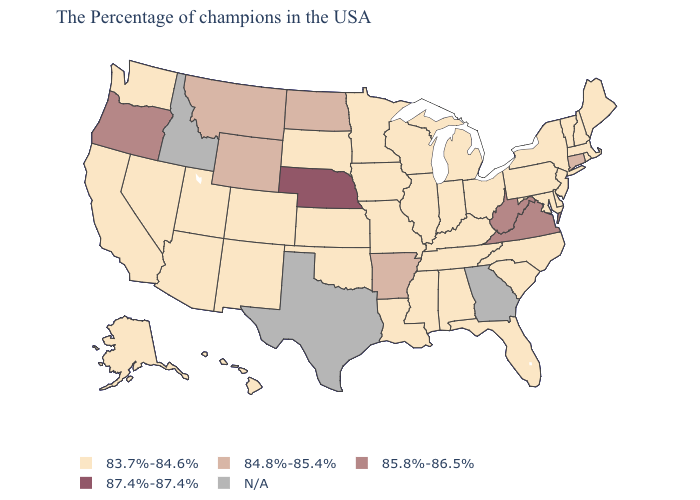Which states have the highest value in the USA?
Short answer required. Nebraska. Name the states that have a value in the range 83.7%-84.6%?
Keep it brief. Maine, Massachusetts, Rhode Island, New Hampshire, Vermont, New York, New Jersey, Delaware, Maryland, Pennsylvania, North Carolina, South Carolina, Ohio, Florida, Michigan, Kentucky, Indiana, Alabama, Tennessee, Wisconsin, Illinois, Mississippi, Louisiana, Missouri, Minnesota, Iowa, Kansas, Oklahoma, South Dakota, Colorado, New Mexico, Utah, Arizona, Nevada, California, Washington, Alaska, Hawaii. Name the states that have a value in the range 83.7%-84.6%?
Keep it brief. Maine, Massachusetts, Rhode Island, New Hampshire, Vermont, New York, New Jersey, Delaware, Maryland, Pennsylvania, North Carolina, South Carolina, Ohio, Florida, Michigan, Kentucky, Indiana, Alabama, Tennessee, Wisconsin, Illinois, Mississippi, Louisiana, Missouri, Minnesota, Iowa, Kansas, Oklahoma, South Dakota, Colorado, New Mexico, Utah, Arizona, Nevada, California, Washington, Alaska, Hawaii. Name the states that have a value in the range 84.8%-85.4%?
Write a very short answer. Connecticut, Arkansas, North Dakota, Wyoming, Montana. Which states have the lowest value in the Northeast?
Quick response, please. Maine, Massachusetts, Rhode Island, New Hampshire, Vermont, New York, New Jersey, Pennsylvania. Does the first symbol in the legend represent the smallest category?
Short answer required. Yes. Does the first symbol in the legend represent the smallest category?
Write a very short answer. Yes. Does the first symbol in the legend represent the smallest category?
Give a very brief answer. Yes. Is the legend a continuous bar?
Give a very brief answer. No. Name the states that have a value in the range 83.7%-84.6%?
Keep it brief. Maine, Massachusetts, Rhode Island, New Hampshire, Vermont, New York, New Jersey, Delaware, Maryland, Pennsylvania, North Carolina, South Carolina, Ohio, Florida, Michigan, Kentucky, Indiana, Alabama, Tennessee, Wisconsin, Illinois, Mississippi, Louisiana, Missouri, Minnesota, Iowa, Kansas, Oklahoma, South Dakota, Colorado, New Mexico, Utah, Arizona, Nevada, California, Washington, Alaska, Hawaii. Name the states that have a value in the range 83.7%-84.6%?
Give a very brief answer. Maine, Massachusetts, Rhode Island, New Hampshire, Vermont, New York, New Jersey, Delaware, Maryland, Pennsylvania, North Carolina, South Carolina, Ohio, Florida, Michigan, Kentucky, Indiana, Alabama, Tennessee, Wisconsin, Illinois, Mississippi, Louisiana, Missouri, Minnesota, Iowa, Kansas, Oklahoma, South Dakota, Colorado, New Mexico, Utah, Arizona, Nevada, California, Washington, Alaska, Hawaii. Does Wyoming have the lowest value in the USA?
Be succinct. No. Does Nevada have the lowest value in the USA?
Answer briefly. Yes. What is the lowest value in the Northeast?
Concise answer only. 83.7%-84.6%. 